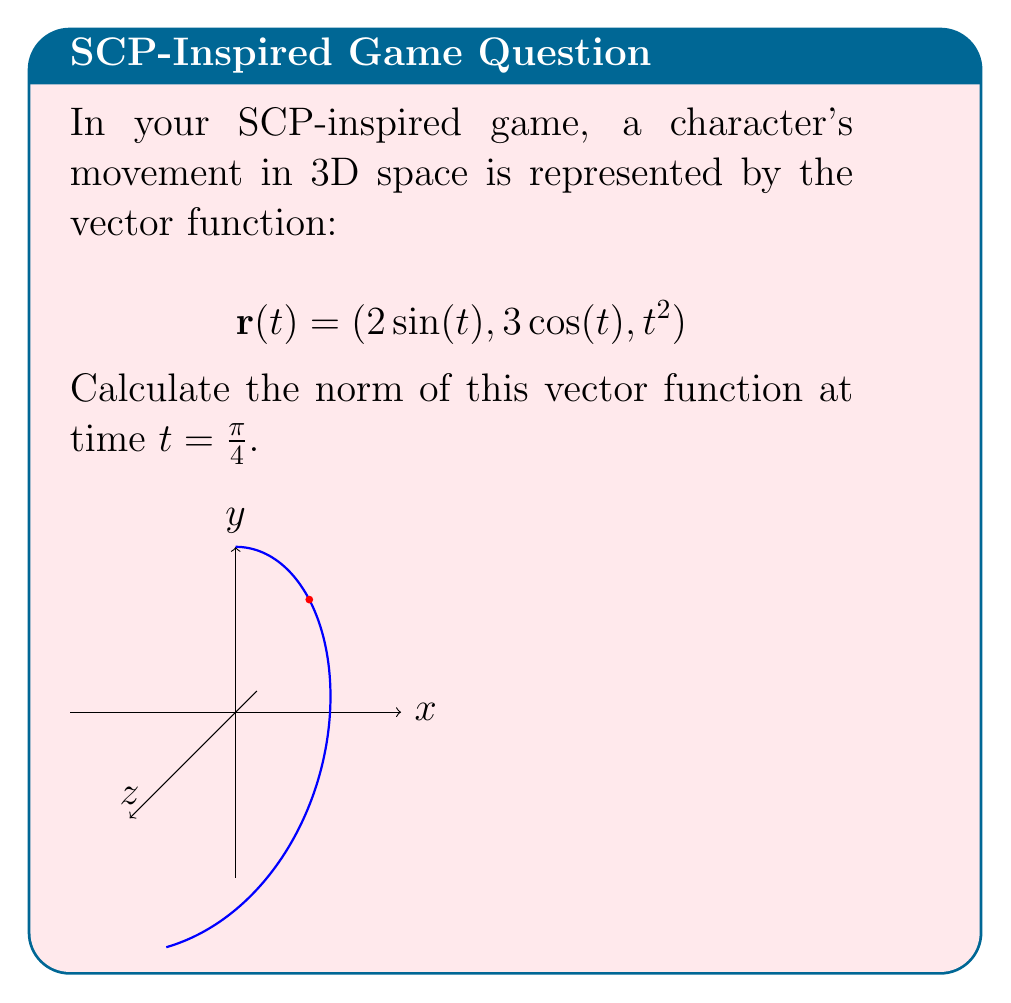Solve this math problem. To solve this problem, we'll follow these steps:

1) The norm of a vector function $\mathbf{r}(t) = (x(t), y(t), z(t))$ is given by:

   $$\|\mathbf{r}(t)\| = \sqrt{x(t)^2 + y(t)^2 + z(t)^2}$$

2) In our case, we have:
   $x(t) = 2\sin(t)$
   $y(t) = 3\cos(t)$
   $z(t) = t^2$

3) We need to calculate this at $t = \pi/4$. Let's substitute this value:

   $x(\pi/4) = 2\sin(\pi/4) = 2 \cdot \frac{\sqrt{2}}{2} = \sqrt{2}$
   $y(\pi/4) = 3\cos(\pi/4) = 3 \cdot \frac{\sqrt{2}}{2} = \frac{3\sqrt{2}}{2}$
   $z(\pi/4) = (\pi/4)^2 = \pi^2/16$

4) Now, let's square each component:

   $x(\pi/4)^2 = (\sqrt{2})^2 = 2$
   $y(\pi/4)^2 = (\frac{3\sqrt{2}}{2})^2 = \frac{18}{4} = \frac{9}{2}$
   $z(\pi/4)^2 = (\pi^2/16)^2 = \pi^4/256$

5) Sum these squares:

   $2 + \frac{9}{2} + \frac{\pi^4}{256} = \frac{4}{2} + \frac{9}{2} + \frac{\pi^4}{256} = \frac{13}{2} + \frac{\pi^4}{256}$

6) Take the square root:

   $$\|\mathbf{r}(\pi/4)\| = \sqrt{\frac{13}{2} + \frac{\pi^4}{256}}$$

This is our final answer.
Answer: $\sqrt{\frac{13}{2} + \frac{\pi^4}{256}}$ 